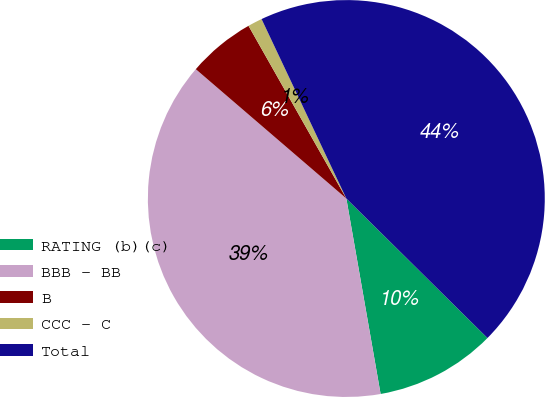<chart> <loc_0><loc_0><loc_500><loc_500><pie_chart><fcel>RATING (b)(c)<fcel>BBB - BB<fcel>B<fcel>CCC - C<fcel>Total<nl><fcel>9.83%<fcel>39.06%<fcel>5.5%<fcel>1.18%<fcel>44.43%<nl></chart> 